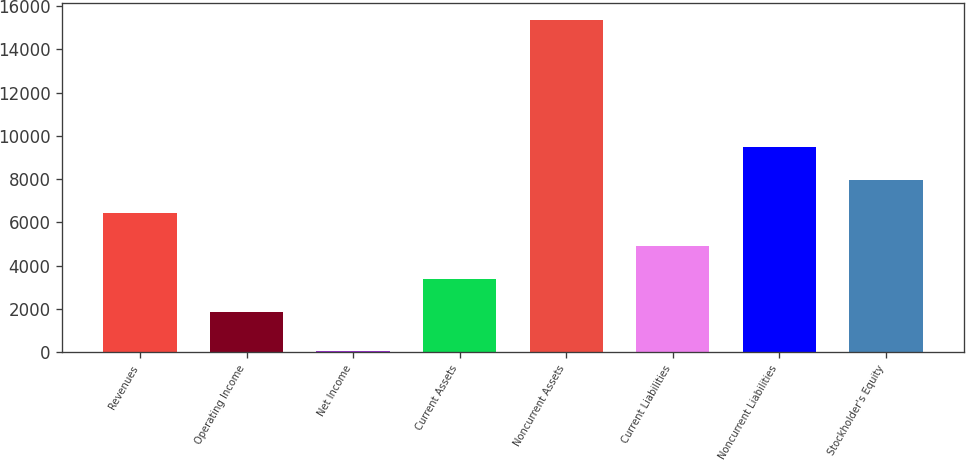<chart> <loc_0><loc_0><loc_500><loc_500><bar_chart><fcel>Revenues<fcel>Operating Income<fcel>Net Income<fcel>Current Assets<fcel>Noncurrent Assets<fcel>Current Liabilities<fcel>Noncurrent Liabilities<fcel>Stockholder's Equity<nl><fcel>6428.1<fcel>1839<fcel>62<fcel>3368.7<fcel>15359<fcel>4898.4<fcel>9487.5<fcel>7957.8<nl></chart> 